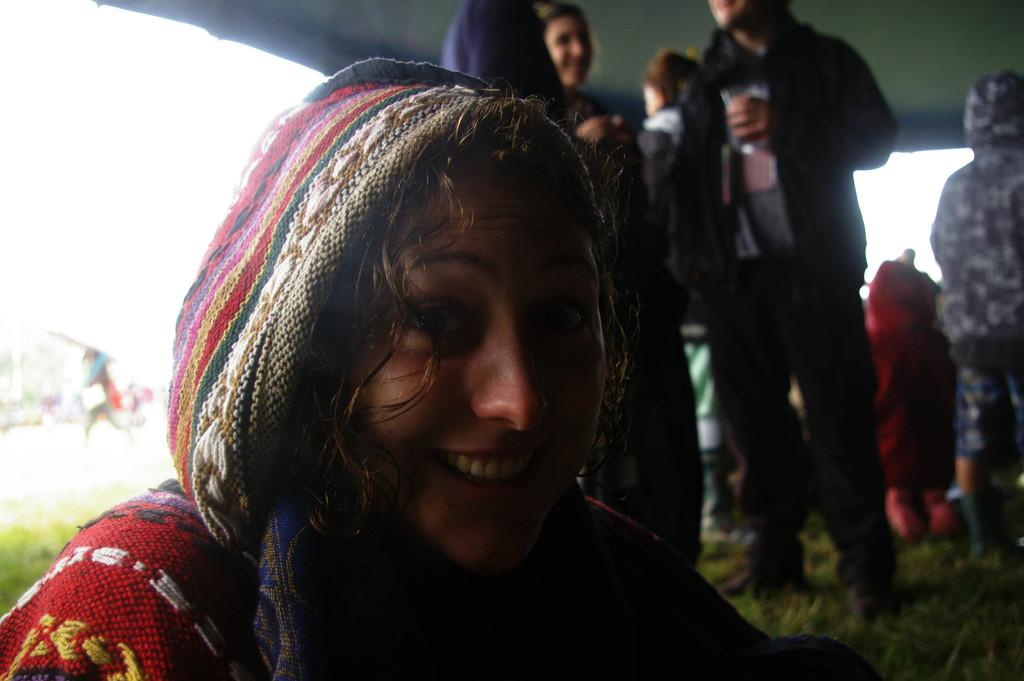Who is the main subject in the image? There is a lady in the image. What is the lady doing in the image? The lady is smiling in the image. How many people are present in the image? There are people standing in the image. What is the surface that the people are standing on? The people are standing on the ground. What type of vegetation is present on the ground? There is grass on the ground. How would you describe the background of the image? The background of the image is blurred. What type of nut can be seen in the image? There is no nut present in the image. How many boys are visible in the image? The image does not specify the gender of the people present, so it is not possible to determine the number of boys. 